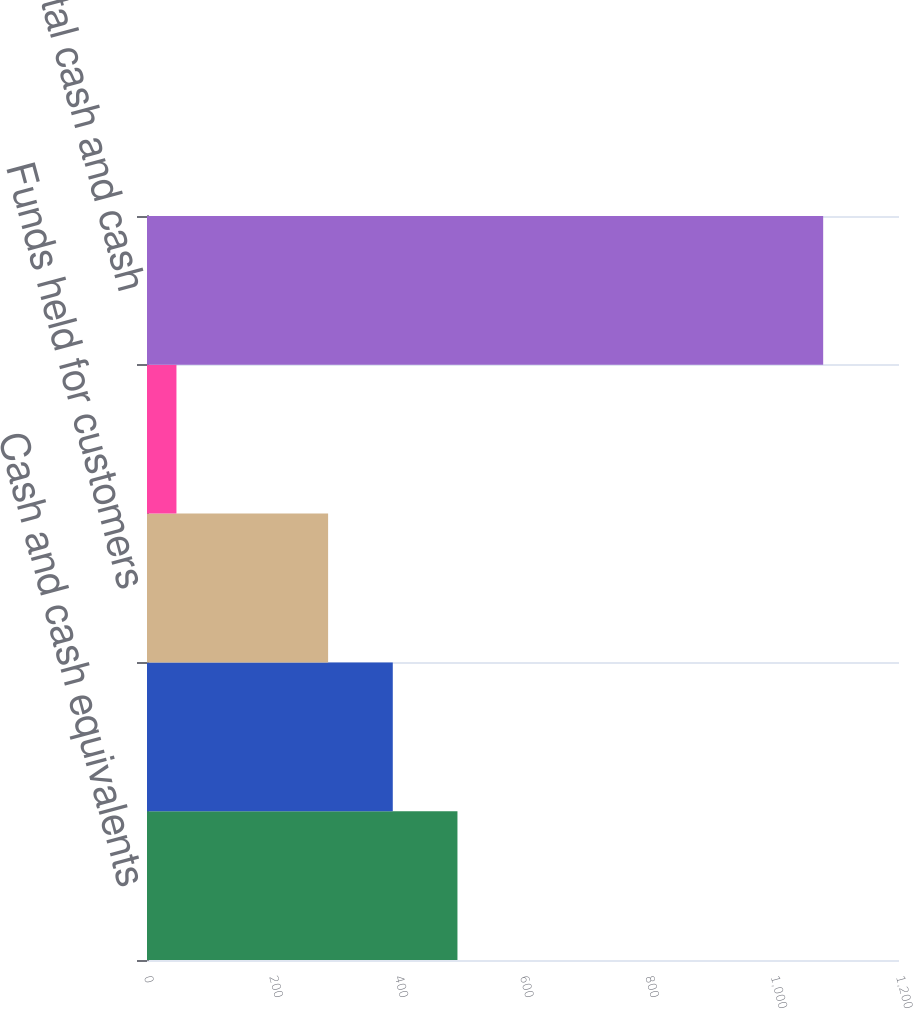Convert chart to OTSL. <chart><loc_0><loc_0><loc_500><loc_500><bar_chart><fcel>Cash and cash equivalents<fcel>Investments<fcel>Funds held for customers<fcel>Long-term investments<fcel>Total cash and cash<nl><fcel>495.4<fcel>392.2<fcel>289<fcel>47<fcel>1079<nl></chart> 